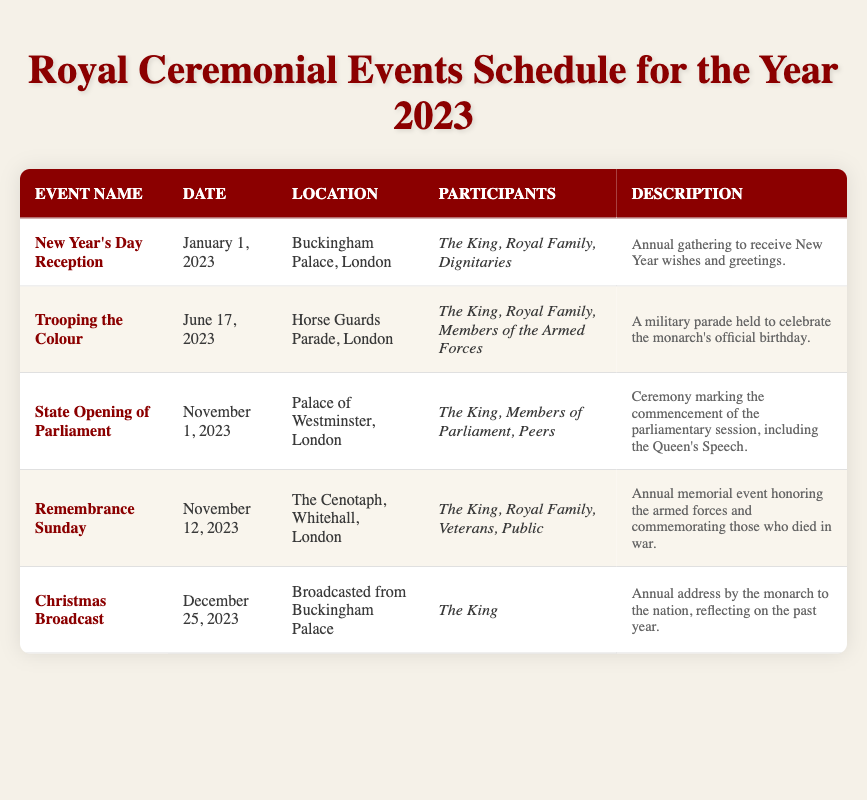What is the date of the New Year’s Day Reception? The table lists the New Year’s Day Reception under the Event Name column, and the corresponding Date column shows January 1, 2023.
Answer: January 1, 2023 Which event takes place at the Palace of Westminster? Looking at the Location column, the State Opening of Parliament is the only event listed with the Palace of Westminster as its location.
Answer: State Opening of Parliament How many events are scheduled for November? By examining the table, there are two events scheduled in November: State Opening of Parliament on November 1 and Remembrance Sunday on November 12. Therefore, the total is 2.
Answer: 2 Is the King a participant in the Christmas Broadcast? According to the Participants column for the Christmas Broadcast, it is specified that only the King is listed as a participant.
Answer: Yes What is the difference in days between Trooping the Colour and Remembrance Sunday? Trooping the Colour is on June 17, 2023, and Remembrance Sunday is on November 12, 2023. To find the difference, first calculate the total days from June 17 to November 12, which is 148 days.
Answer: 148 days How many different locations are mentioned in the event schedule? The table provides three distinct locations: Buckingham Palace, Horse Guards Parade, and Palace of Westminster, plus The Cenotaph (noting that Buckingham Palace is mentioned twice but counts as one unique location). Hence, there are four unique locations overall.
Answer: 4 Does the Trooping the Colour event have the Royal Family as participants? Looking in the Participants column for Trooping the Colour, it clearly lists the Royal Family as one of the participants.
Answer: Yes Which event occurs first in the year? By reviewing the dates provided in the table, New Year’s Day Reception on January 1 is the earliest event listed for the year.
Answer: New Year’s Day Reception How many participants are listed for the Remembrance Sunday event? The Participants column lists four participants: The King, Royal Family, Veterans, and the Public. Therefore, the total number of participants for Remembrance Sunday is four.
Answer: 4 